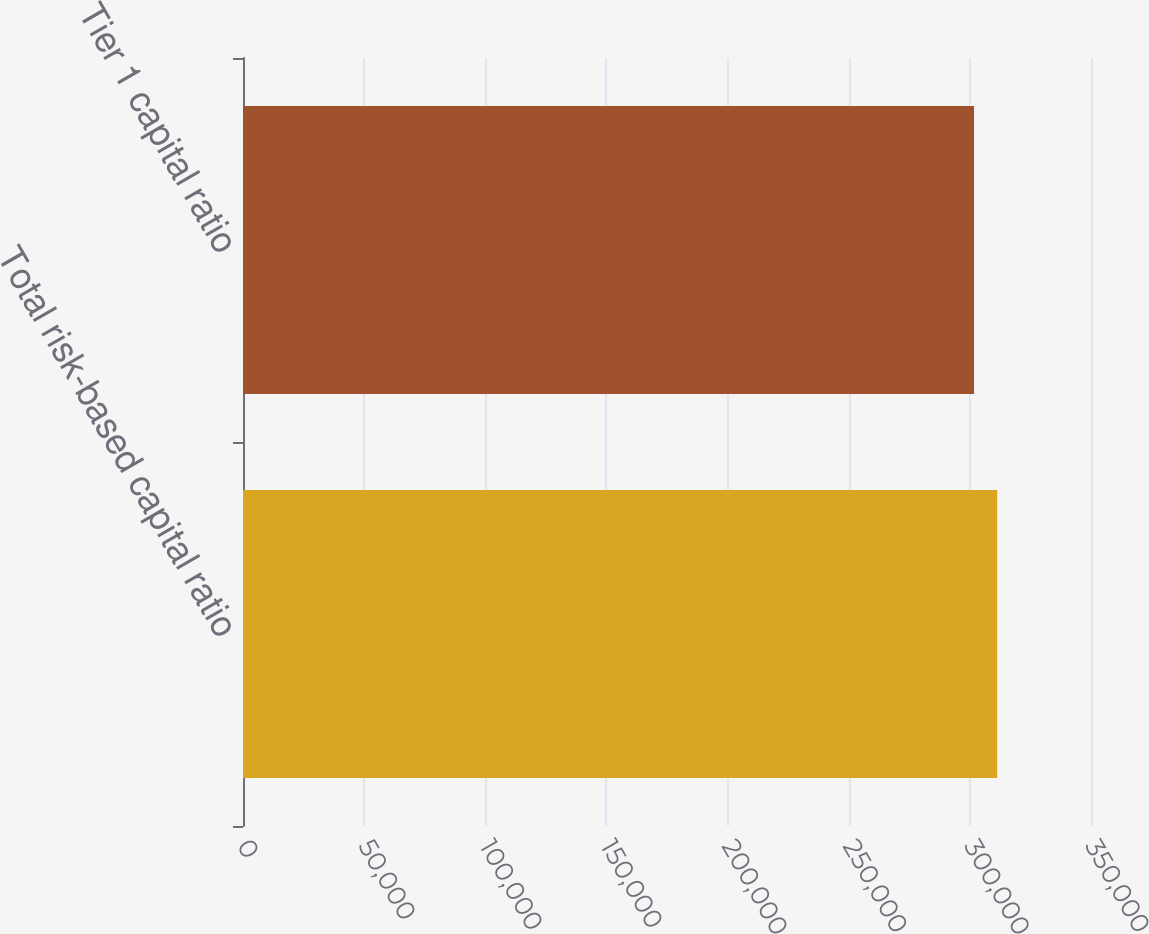<chart> <loc_0><loc_0><loc_500><loc_500><bar_chart><fcel>Total risk-based capital ratio<fcel>Tier 1 capital ratio<nl><fcel>311281<fcel>301718<nl></chart> 